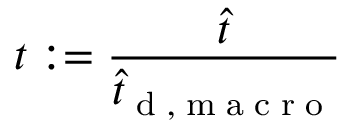Convert formula to latex. <formula><loc_0><loc_0><loc_500><loc_500>t \colon = \frac { \hat { t } } { \hat { t } _ { d , m a c r o } }</formula> 